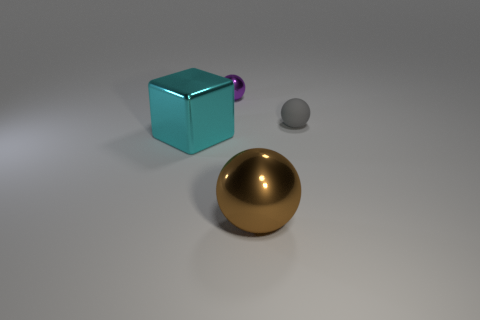There is a tiny ball on the right side of the big shiny object that is to the right of the cyan cube; how many small objects are to the left of it?
Ensure brevity in your answer.  1. How many gray objects are large metal cubes or tiny metal objects?
Ensure brevity in your answer.  0. Is the size of the purple ball the same as the metal thing that is in front of the cyan metal cube?
Keep it short and to the point. No. What material is the brown object that is the same shape as the tiny purple shiny thing?
Ensure brevity in your answer.  Metal. What is the shape of the large thing that is left of the sphere behind the small gray matte thing to the right of the large brown sphere?
Your answer should be compact. Cube. The object that is in front of the matte sphere and left of the large brown thing has what shape?
Your response must be concise. Cube. What number of things are small purple metallic spheres or metal balls left of the large brown thing?
Your response must be concise. 1. Is the big brown sphere made of the same material as the block?
Make the answer very short. Yes. What number of other things are there of the same shape as the rubber thing?
Your answer should be very brief. 2. There is a metal object that is both in front of the tiny metallic object and on the right side of the cyan shiny block; what size is it?
Keep it short and to the point. Large. 